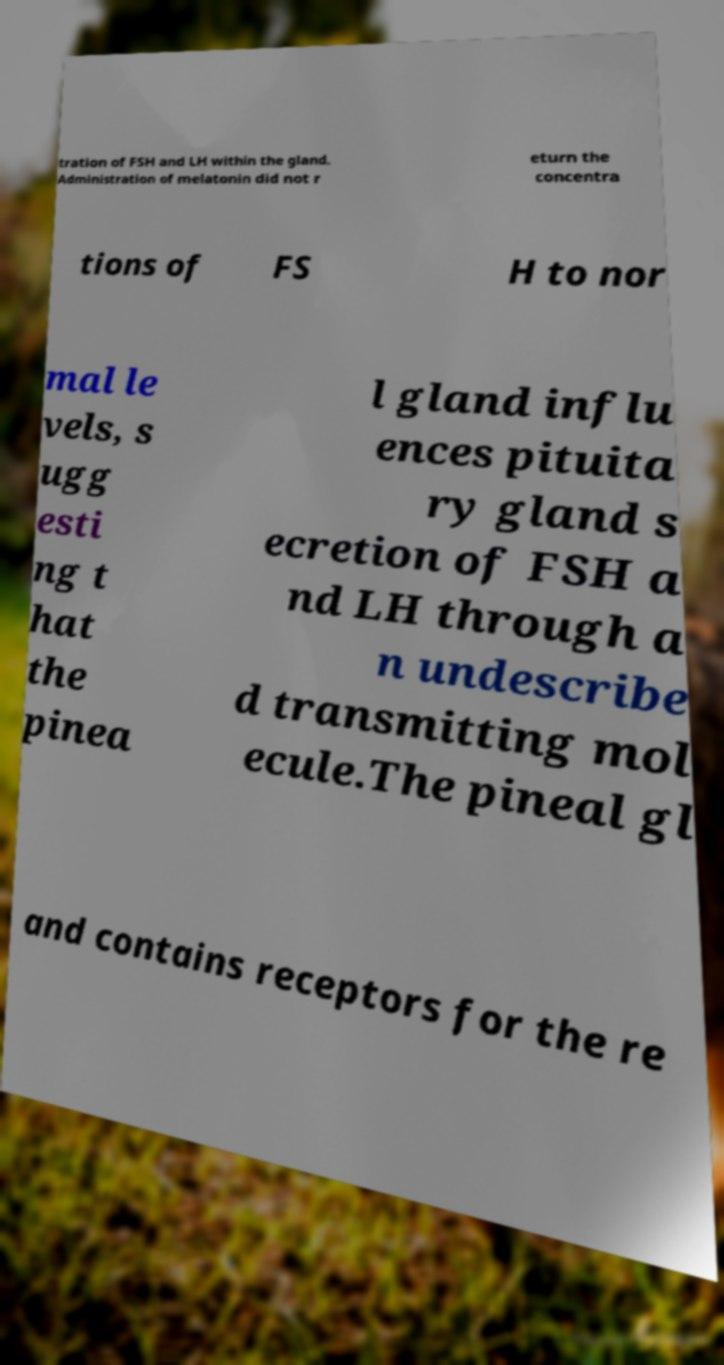There's text embedded in this image that I need extracted. Can you transcribe it verbatim? tration of FSH and LH within the gland. Administration of melatonin did not r eturn the concentra tions of FS H to nor mal le vels, s ugg esti ng t hat the pinea l gland influ ences pituita ry gland s ecretion of FSH a nd LH through a n undescribe d transmitting mol ecule.The pineal gl and contains receptors for the re 